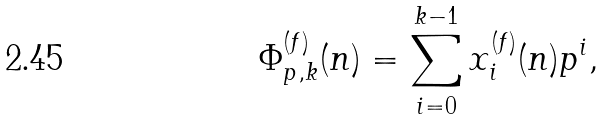Convert formula to latex. <formula><loc_0><loc_0><loc_500><loc_500>\Phi ^ { ( f ) } _ { p , k } ( n ) = \sum _ { i = 0 } ^ { k - 1 } x ^ { ( f ) } _ { i } ( n ) p ^ { i } ,</formula> 